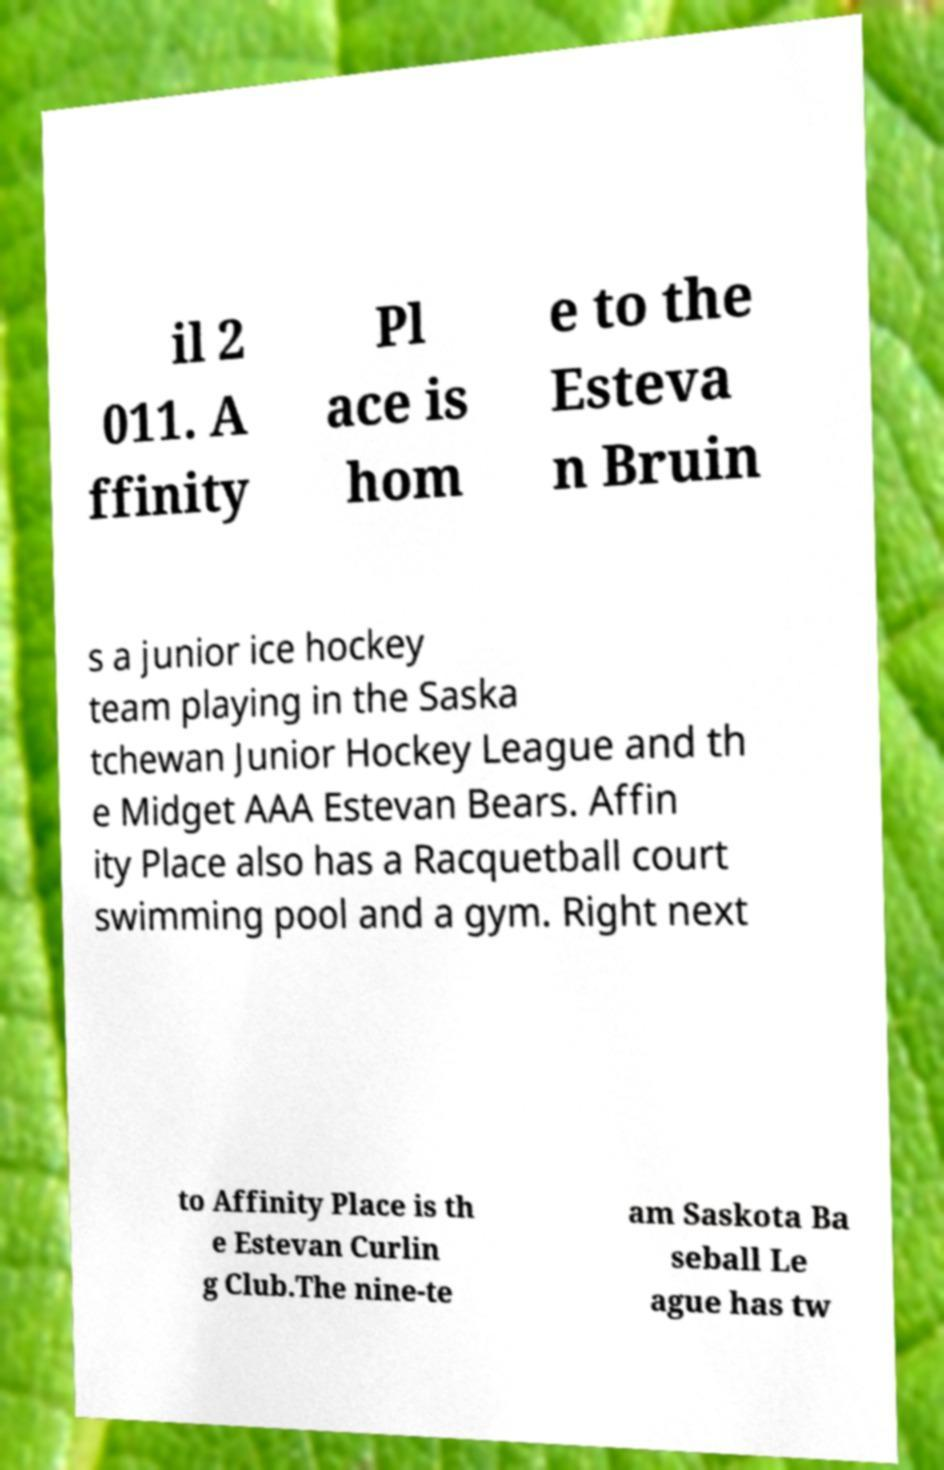I need the written content from this picture converted into text. Can you do that? il 2 011. A ffinity Pl ace is hom e to the Esteva n Bruin s a junior ice hockey team playing in the Saska tchewan Junior Hockey League and th e Midget AAA Estevan Bears. Affin ity Place also has a Racquetball court swimming pool and a gym. Right next to Affinity Place is th e Estevan Curlin g Club.The nine-te am Saskota Ba seball Le ague has tw 